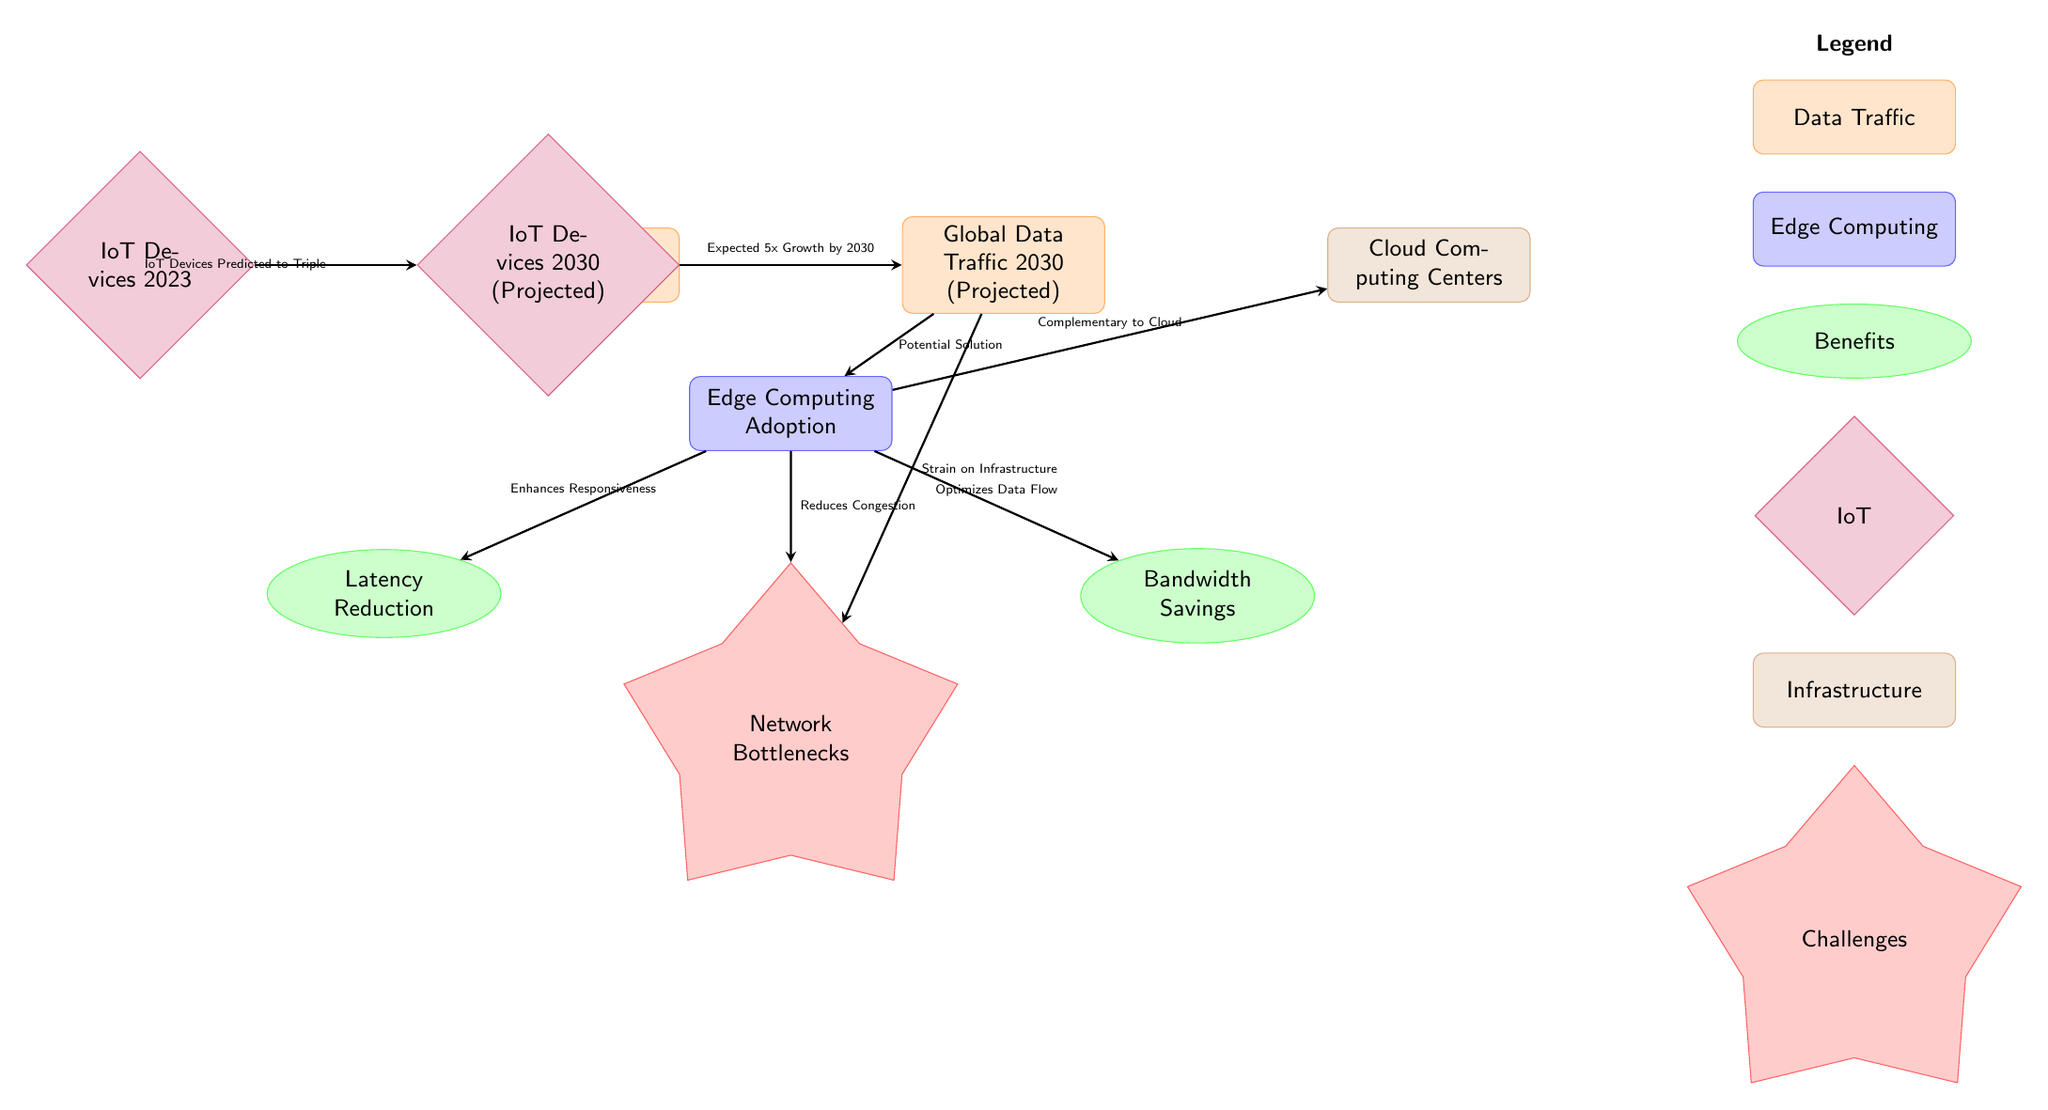What is the expected growth of global data traffic by 2030? The diagram indicates that the expected growth of global data traffic from 2023 to 2030 is five times. This information is found in the arrow connecting the two nodes for global data traffic.
Answer: 5x How many types of benefits are listed in the diagram? By counting the benefit nodes under "Edge Computing Adoption", there are two types listed: Latency Reduction and Bandwidth Savings.
Answer: 2 What are the two projected types of IoT devices in 2023 and 2030? The diagram specifies that IoT devices are represented at both years, with current IoT devices shown for 2023 and projected IoT devices expected to triple by 2030.
Answer: Current IoT Devices and Projected IoT Devices What is the primary challenge depicted related to the increased global data traffic? The diagram illustrates "Network Bottlenecks" as the major challenge that arises due to the anticipated strain on infrastructure from increased data traffic.
Answer: Network Bottlenecks How does edge computing contribute to data flow according to the diagram? The diagram shows an arrow from "Edge Computing Adoption" to "Bandwidth Savings", indicating that edge computing optimizes data flow, effectively relieving some bandwidth concerns.
Answer: Optimizes Data Flow What is the role of edge computing in relation to cloud computing as depicted? The diagram shows a connection from "Edge Computing Adoption" to "Cloud Computing Centers", describing edge computing as a complement to cloud computing, meaning they work together rather than one replacing the other.
Answer: Complementary to Cloud What is the predicted number of IoT devices from 2023 to 2030? The description correlates IoT devices in 2023 to a projected tripling by 2030, indicating a significant increase in the number of devices, reflecting substantial growth in IoT technology.
Answer: Tripling Which node represents a potential solution to infrastructure strain? The diagram clearly indicates "Edge Computing Adoption" as the node that serves as a potential solution to the challenges represented by the projected data increase and its strain on infrastructure.
Answer: Edge Computing Adoption 